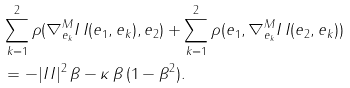<formula> <loc_0><loc_0><loc_500><loc_500>& \sum _ { k = 1 } ^ { 2 } \rho ( \nabla _ { e _ { k } } ^ { M } I \, I ( e _ { 1 } , e _ { k } ) , e _ { 2 } ) + \sum _ { k = 1 } ^ { 2 } \rho ( e _ { 1 } , \nabla _ { e _ { k } } ^ { M } I \, I ( e _ { 2 } , e _ { k } ) ) \\ & = - | I \, I | ^ { 2 } \, \beta - \kappa \, \beta \, ( 1 - \beta ^ { 2 } ) .</formula> 